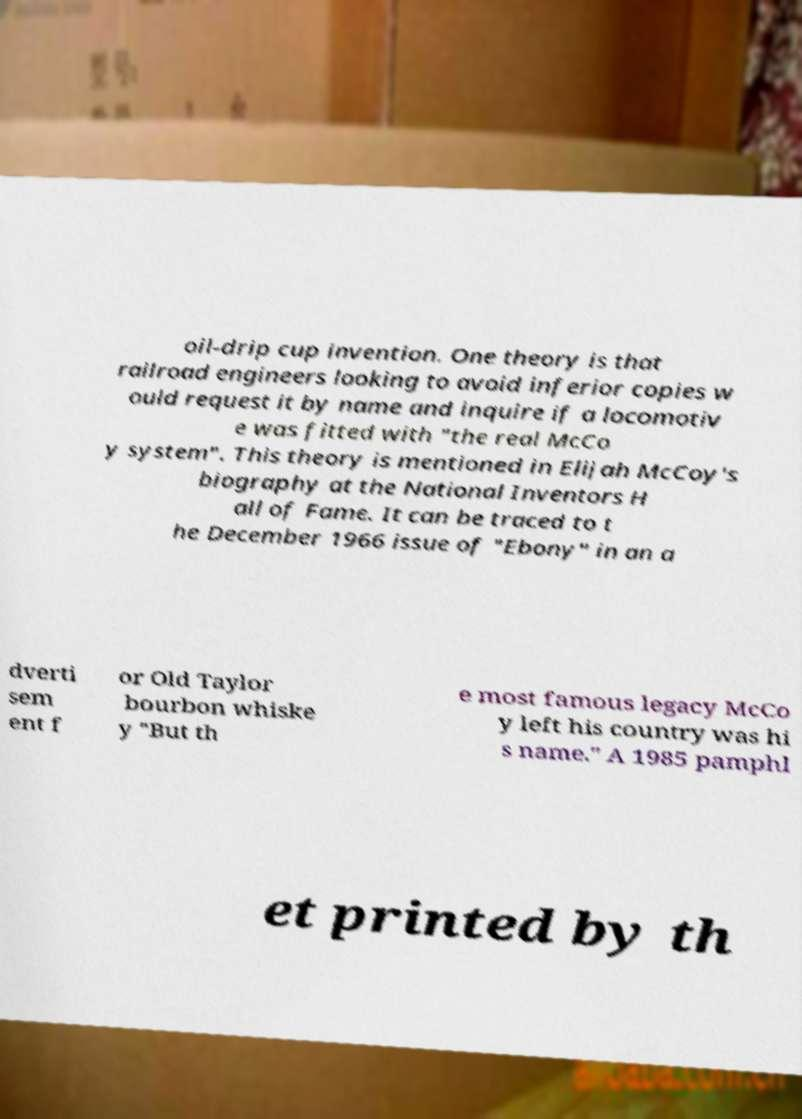Could you extract and type out the text from this image? oil-drip cup invention. One theory is that railroad engineers looking to avoid inferior copies w ould request it by name and inquire if a locomotiv e was fitted with "the real McCo y system". This theory is mentioned in Elijah McCoy's biography at the National Inventors H all of Fame. It can be traced to t he December 1966 issue of "Ebony" in an a dverti sem ent f or Old Taylor bourbon whiske y "But th e most famous legacy McCo y left his country was hi s name." A 1985 pamphl et printed by th 